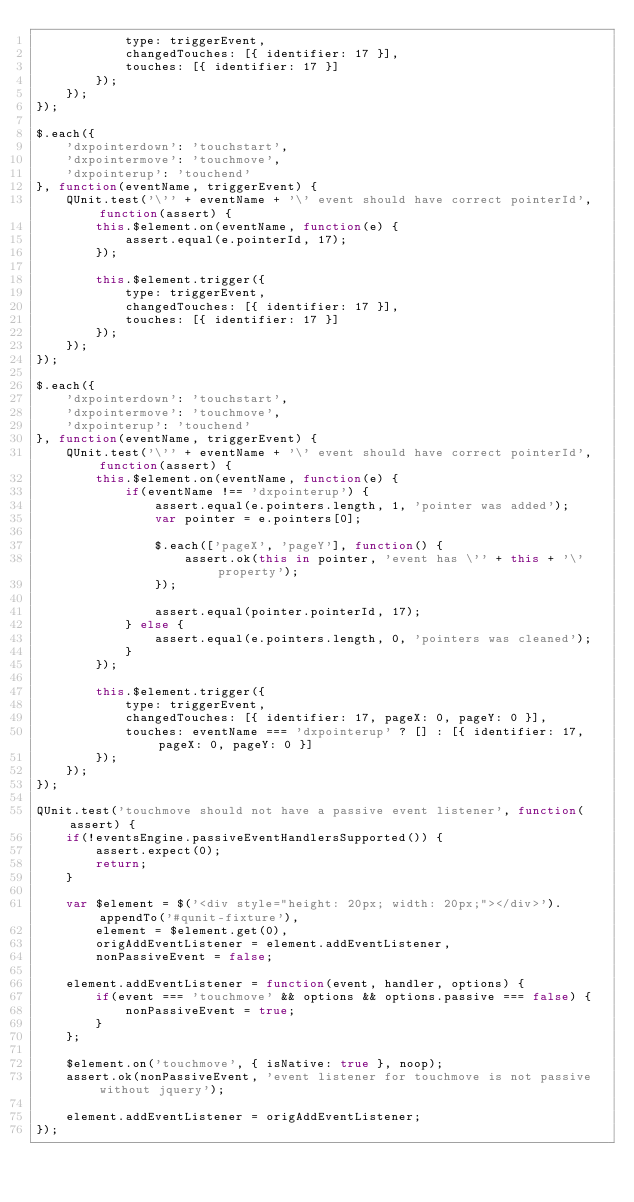<code> <loc_0><loc_0><loc_500><loc_500><_JavaScript_>            type: triggerEvent,
            changedTouches: [{ identifier: 17 }],
            touches: [{ identifier: 17 }]
        });
    });
});

$.each({
    'dxpointerdown': 'touchstart',
    'dxpointermove': 'touchmove',
    'dxpointerup': 'touchend'
}, function(eventName, triggerEvent) {
    QUnit.test('\'' + eventName + '\' event should have correct pointerId', function(assert) {
        this.$element.on(eventName, function(e) {
            assert.equal(e.pointerId, 17);
        });

        this.$element.trigger({
            type: triggerEvent,
            changedTouches: [{ identifier: 17 }],
            touches: [{ identifier: 17 }]
        });
    });
});

$.each({
    'dxpointerdown': 'touchstart',
    'dxpointermove': 'touchmove',
    'dxpointerup': 'touchend'
}, function(eventName, triggerEvent) {
    QUnit.test('\'' + eventName + '\' event should have correct pointerId', function(assert) {
        this.$element.on(eventName, function(e) {
            if(eventName !== 'dxpointerup') {
                assert.equal(e.pointers.length, 1, 'pointer was added');
                var pointer = e.pointers[0];

                $.each(['pageX', 'pageY'], function() {
                    assert.ok(this in pointer, 'event has \'' + this + '\' property');
                });

                assert.equal(pointer.pointerId, 17);
            } else {
                assert.equal(e.pointers.length, 0, 'pointers was cleaned');
            }
        });

        this.$element.trigger({
            type: triggerEvent,
            changedTouches: [{ identifier: 17, pageX: 0, pageY: 0 }],
            touches: eventName === 'dxpointerup' ? [] : [{ identifier: 17, pageX: 0, pageY: 0 }]
        });
    });
});

QUnit.test('touchmove should not have a passive event listener', function(assert) {
    if(!eventsEngine.passiveEventHandlersSupported()) {
        assert.expect(0);
        return;
    }

    var $element = $('<div style="height: 20px; width: 20px;"></div>').appendTo('#qunit-fixture'),
        element = $element.get(0),
        origAddEventListener = element.addEventListener,
        nonPassiveEvent = false;

    element.addEventListener = function(event, handler, options) {
        if(event === 'touchmove' && options && options.passive === false) {
            nonPassiveEvent = true;
        }
    };

    $element.on('touchmove', { isNative: true }, noop);
    assert.ok(nonPassiveEvent, 'event listener for touchmove is not passive without jquery');

    element.addEventListener = origAddEventListener;
});
</code> 